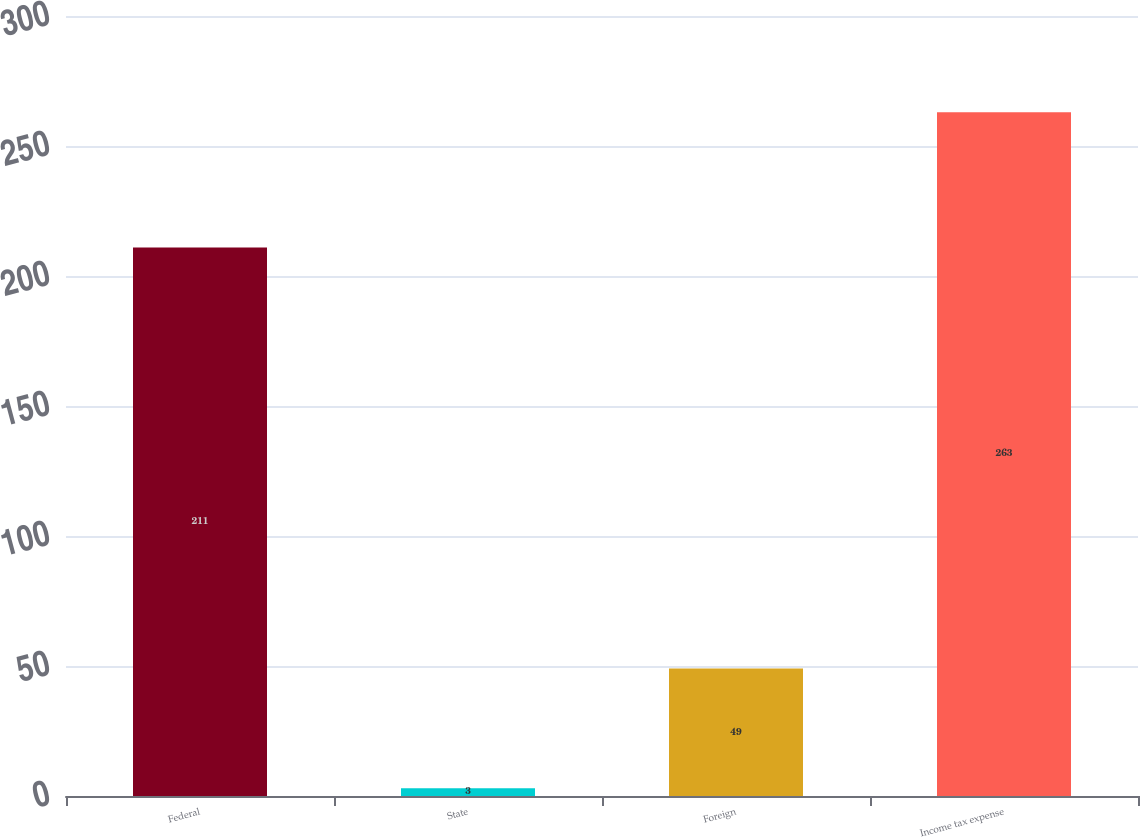Convert chart. <chart><loc_0><loc_0><loc_500><loc_500><bar_chart><fcel>Federal<fcel>State<fcel>Foreign<fcel>Income tax expense<nl><fcel>211<fcel>3<fcel>49<fcel>263<nl></chart> 